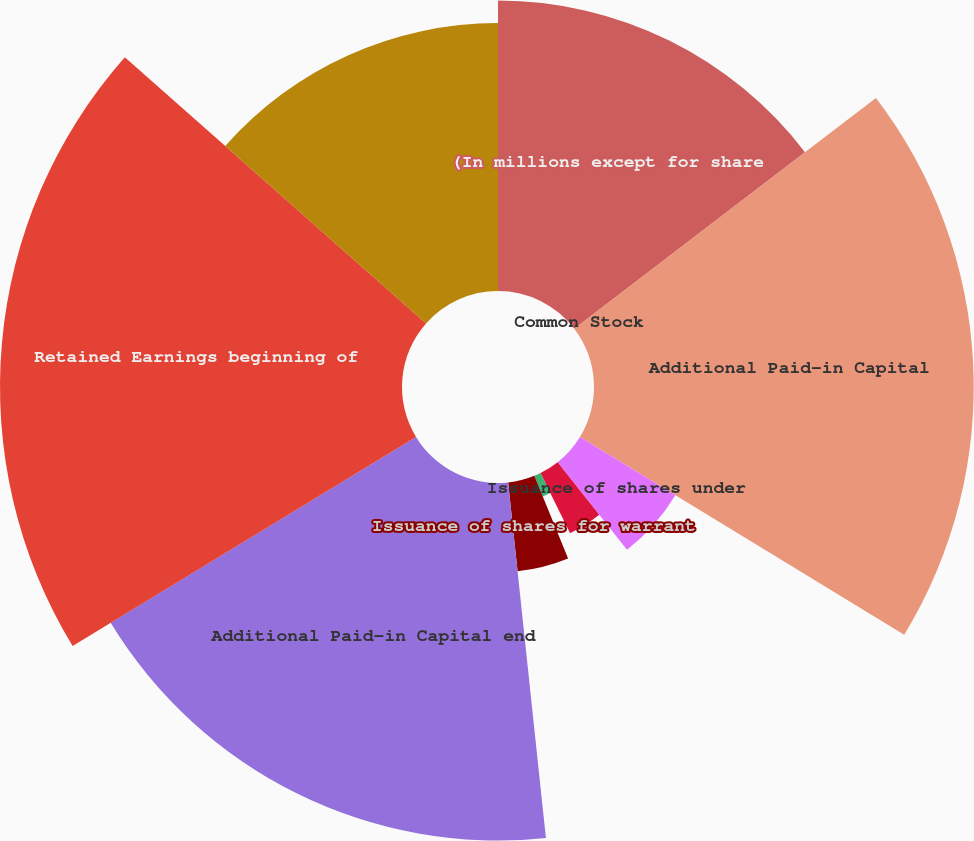<chart> <loc_0><loc_0><loc_500><loc_500><pie_chart><fcel>(In millions except for share<fcel>Common Stock<fcel>Additional Paid-in Capital<fcel>Issuance of shares under<fcel>Stock-based compensation plans<fcel>Tax benefit on employee stock<fcel>Issuance of shares for warrant<fcel>Additional Paid-in Capital end<fcel>Retained Earnings beginning of<fcel>Net income<nl><fcel>14.61%<fcel>0.0%<fcel>19.1%<fcel>5.62%<fcel>3.37%<fcel>1.12%<fcel>4.49%<fcel>17.98%<fcel>20.22%<fcel>13.48%<nl></chart> 